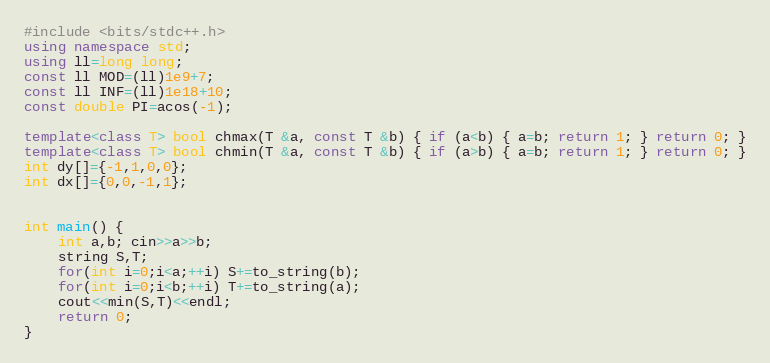Convert code to text. <code><loc_0><loc_0><loc_500><loc_500><_C++_>#include <bits/stdc++.h>
using namespace std;
using ll=long long;
const ll MOD=(ll)1e9+7;
const ll INF=(ll)1e18+10;
const double PI=acos(-1);

template<class T> bool chmax(T &a, const T &b) { if (a<b) { a=b; return 1; } return 0; }
template<class T> bool chmin(T &a, const T &b) { if (a>b) { a=b; return 1; } return 0; }
int dy[]={-1,1,0,0};
int dx[]={0,0,-1,1};


int main() {
    int a,b; cin>>a>>b;
    string S,T;
    for(int i=0;i<a;++i) S+=to_string(b);
    for(int i=0;i<b;++i) T+=to_string(a);
    cout<<min(S,T)<<endl;
    return 0;
}
</code> 